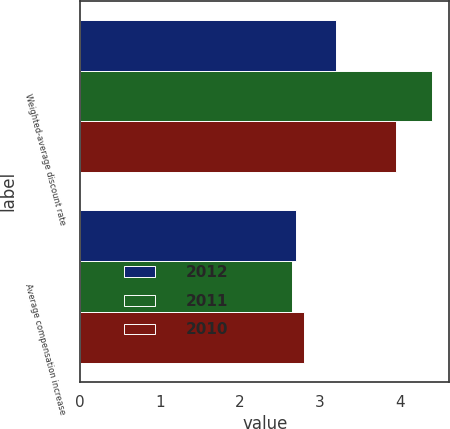Convert chart to OTSL. <chart><loc_0><loc_0><loc_500><loc_500><stacked_bar_chart><ecel><fcel>Weighted-average discount rate<fcel>Average compensation increase<nl><fcel>2012<fcel>3.2<fcel>2.7<nl><fcel>2011<fcel>4.4<fcel>2.65<nl><fcel>2010<fcel>3.95<fcel>2.8<nl></chart> 